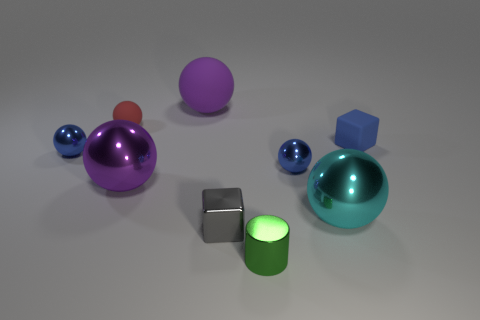Is the number of cyan balls that are left of the tiny gray object greater than the number of red metallic cylinders? No, the number of cyan balls to the left of the tiny gray object, which appears to be two, is not greater than the number of red metallic cylinders, because there are no red metallic cylinders present in the image. 